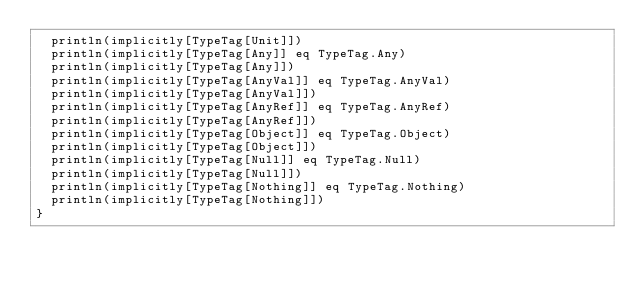<code> <loc_0><loc_0><loc_500><loc_500><_Scala_>  println(implicitly[TypeTag[Unit]])
  println(implicitly[TypeTag[Any]] eq TypeTag.Any)
  println(implicitly[TypeTag[Any]])
  println(implicitly[TypeTag[AnyVal]] eq TypeTag.AnyVal)
  println(implicitly[TypeTag[AnyVal]])
  println(implicitly[TypeTag[AnyRef]] eq TypeTag.AnyRef)
  println(implicitly[TypeTag[AnyRef]])
  println(implicitly[TypeTag[Object]] eq TypeTag.Object)
  println(implicitly[TypeTag[Object]])
  println(implicitly[TypeTag[Null]] eq TypeTag.Null)
  println(implicitly[TypeTag[Null]])
  println(implicitly[TypeTag[Nothing]] eq TypeTag.Nothing)
  println(implicitly[TypeTag[Nothing]])
}
</code> 